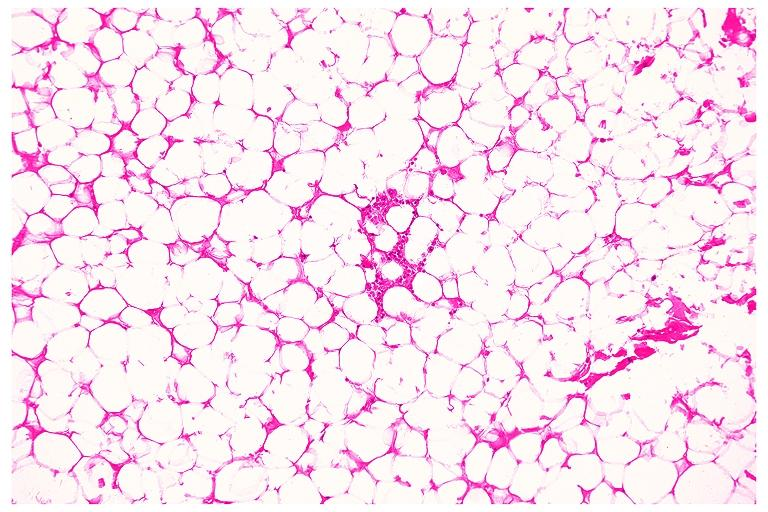where is this?
Answer the question using a single word or phrase. Oral 